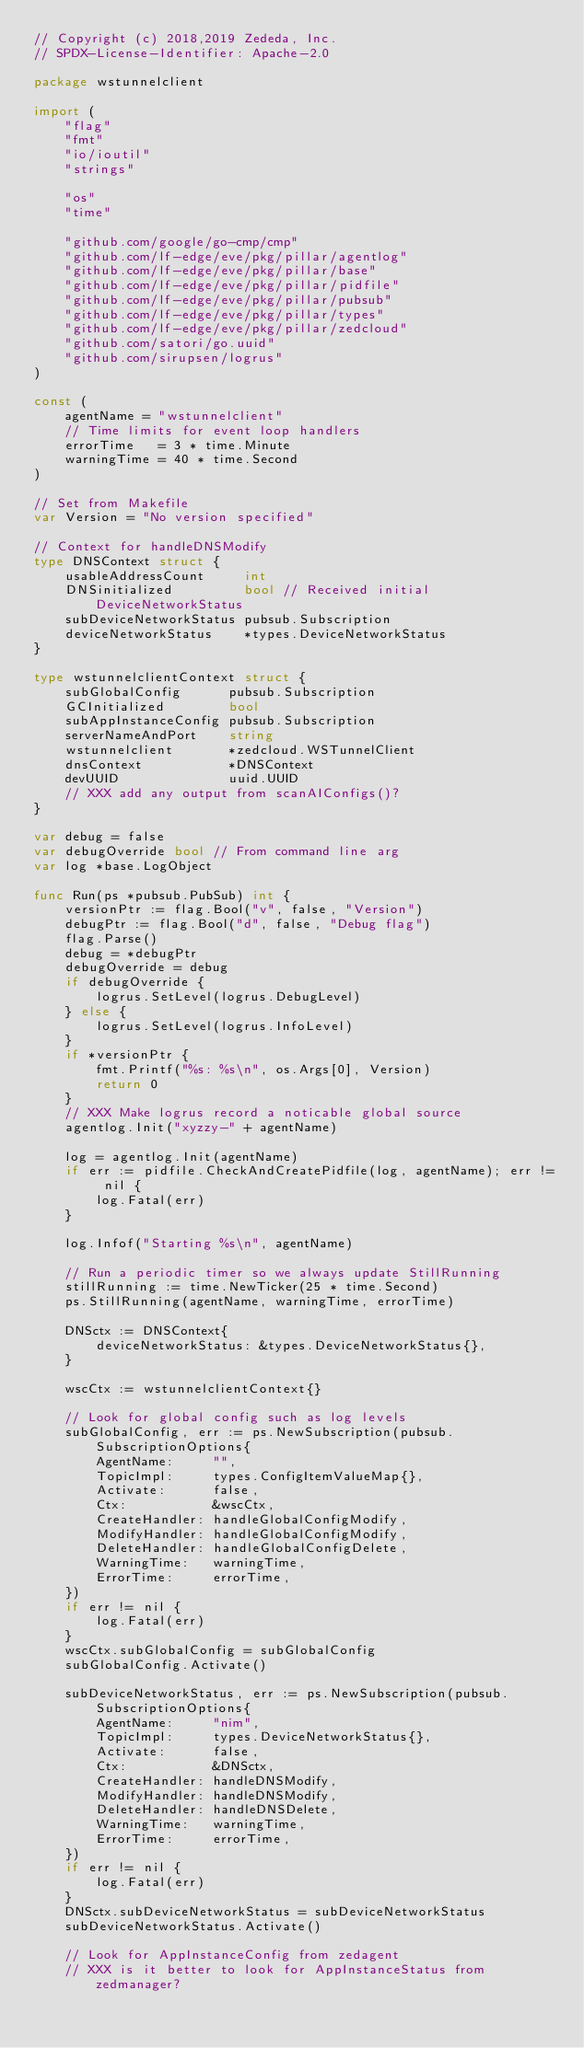Convert code to text. <code><loc_0><loc_0><loc_500><loc_500><_Go_>// Copyright (c) 2018,2019 Zededa, Inc.
// SPDX-License-Identifier: Apache-2.0

package wstunnelclient

import (
	"flag"
	"fmt"
	"io/ioutil"
	"strings"

	"os"
	"time"

	"github.com/google/go-cmp/cmp"
	"github.com/lf-edge/eve/pkg/pillar/agentlog"
	"github.com/lf-edge/eve/pkg/pillar/base"
	"github.com/lf-edge/eve/pkg/pillar/pidfile"
	"github.com/lf-edge/eve/pkg/pillar/pubsub"
	"github.com/lf-edge/eve/pkg/pillar/types"
	"github.com/lf-edge/eve/pkg/pillar/zedcloud"
	"github.com/satori/go.uuid"
	"github.com/sirupsen/logrus"
)

const (
	agentName = "wstunnelclient"
	// Time limits for event loop handlers
	errorTime   = 3 * time.Minute
	warningTime = 40 * time.Second
)

// Set from Makefile
var Version = "No version specified"

// Context for handleDNSModify
type DNSContext struct {
	usableAddressCount     int
	DNSinitialized         bool // Received initial DeviceNetworkStatus
	subDeviceNetworkStatus pubsub.Subscription
	deviceNetworkStatus    *types.DeviceNetworkStatus
}

type wstunnelclientContext struct {
	subGlobalConfig      pubsub.Subscription
	GCInitialized        bool
	subAppInstanceConfig pubsub.Subscription
	serverNameAndPort    string
	wstunnelclient       *zedcloud.WSTunnelClient
	dnsContext           *DNSContext
	devUUID              uuid.UUID
	// XXX add any output from scanAIConfigs()?
}

var debug = false
var debugOverride bool // From command line arg
var log *base.LogObject

func Run(ps *pubsub.PubSub) int {
	versionPtr := flag.Bool("v", false, "Version")
	debugPtr := flag.Bool("d", false, "Debug flag")
	flag.Parse()
	debug = *debugPtr
	debugOverride = debug
	if debugOverride {
		logrus.SetLevel(logrus.DebugLevel)
	} else {
		logrus.SetLevel(logrus.InfoLevel)
	}
	if *versionPtr {
		fmt.Printf("%s: %s\n", os.Args[0], Version)
		return 0
	}
	// XXX Make logrus record a noticable global source
	agentlog.Init("xyzzy-" + agentName)

	log = agentlog.Init(agentName)
	if err := pidfile.CheckAndCreatePidfile(log, agentName); err != nil {
		log.Fatal(err)
	}

	log.Infof("Starting %s\n", agentName)

	// Run a periodic timer so we always update StillRunning
	stillRunning := time.NewTicker(25 * time.Second)
	ps.StillRunning(agentName, warningTime, errorTime)

	DNSctx := DNSContext{
		deviceNetworkStatus: &types.DeviceNetworkStatus{},
	}

	wscCtx := wstunnelclientContext{}

	// Look for global config such as log levels
	subGlobalConfig, err := ps.NewSubscription(pubsub.SubscriptionOptions{
		AgentName:     "",
		TopicImpl:     types.ConfigItemValueMap{},
		Activate:      false,
		Ctx:           &wscCtx,
		CreateHandler: handleGlobalConfigModify,
		ModifyHandler: handleGlobalConfigModify,
		DeleteHandler: handleGlobalConfigDelete,
		WarningTime:   warningTime,
		ErrorTime:     errorTime,
	})
	if err != nil {
		log.Fatal(err)
	}
	wscCtx.subGlobalConfig = subGlobalConfig
	subGlobalConfig.Activate()

	subDeviceNetworkStatus, err := ps.NewSubscription(pubsub.SubscriptionOptions{
		AgentName:     "nim",
		TopicImpl:     types.DeviceNetworkStatus{},
		Activate:      false,
		Ctx:           &DNSctx,
		CreateHandler: handleDNSModify,
		ModifyHandler: handleDNSModify,
		DeleteHandler: handleDNSDelete,
		WarningTime:   warningTime,
		ErrorTime:     errorTime,
	})
	if err != nil {
		log.Fatal(err)
	}
	DNSctx.subDeviceNetworkStatus = subDeviceNetworkStatus
	subDeviceNetworkStatus.Activate()

	// Look for AppInstanceConfig from zedagent
	// XXX is it better to look for AppInstanceStatus from zedmanager?</code> 